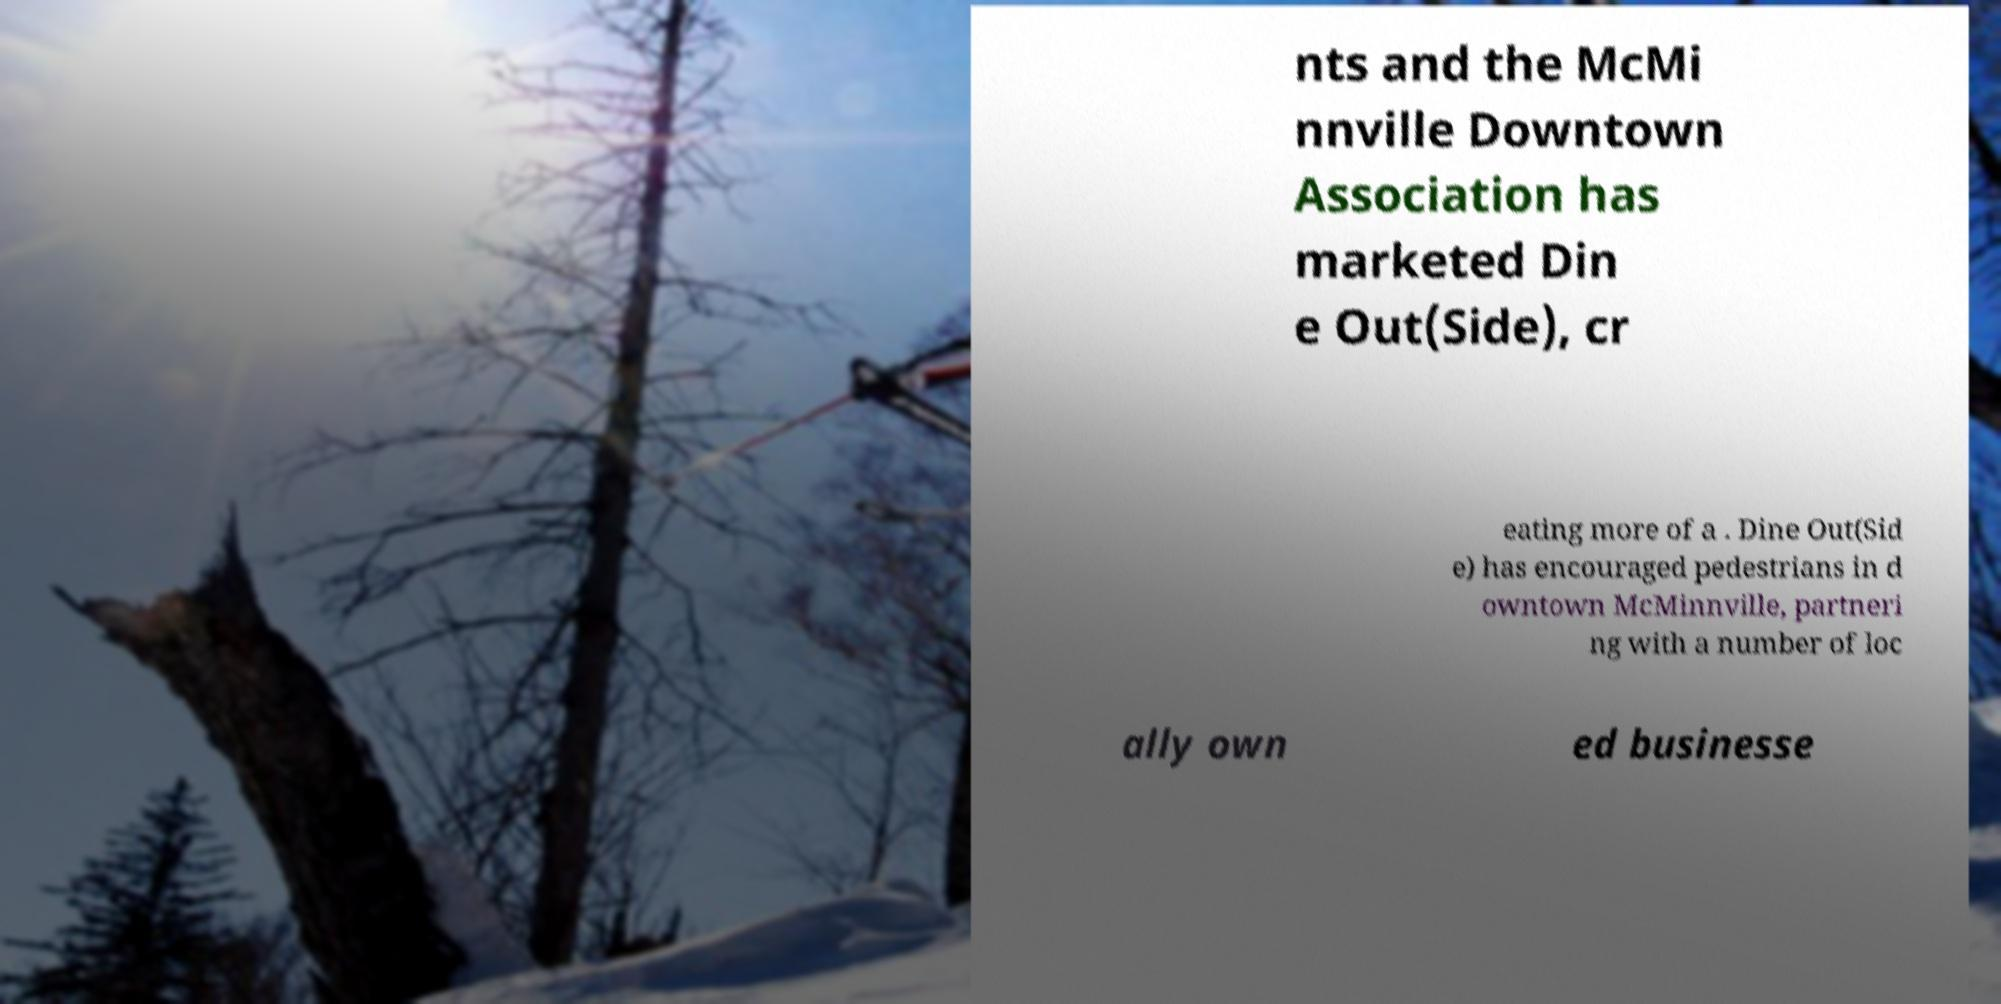Please read and relay the text visible in this image. What does it say? nts and the McMi nnville Downtown Association has marketed Din e Out(Side), cr eating more of a . Dine Out(Sid e) has encouraged pedestrians in d owntown McMinnville, partneri ng with a number of loc ally own ed businesse 